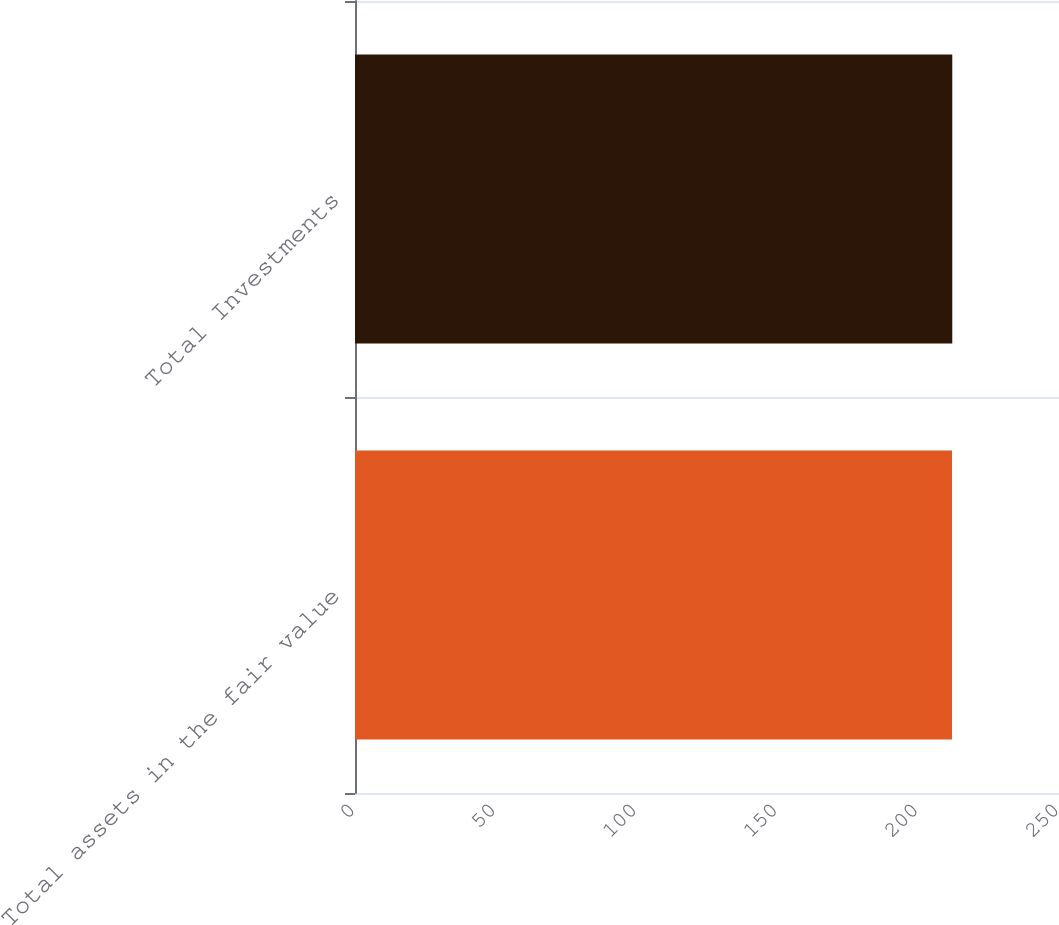Convert chart to OTSL. <chart><loc_0><loc_0><loc_500><loc_500><bar_chart><fcel>Total assets in the fair value<fcel>Total Investments<nl><fcel>212<fcel>212.1<nl></chart> 